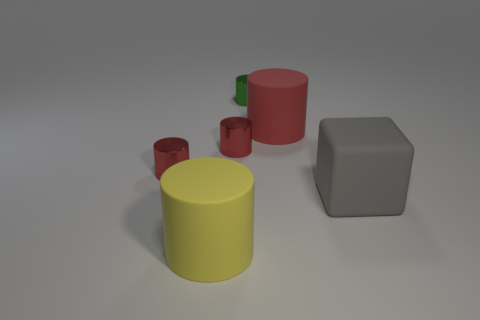How many red cylinders must be subtracted to get 2 red cylinders? 1 Subtract all red spheres. How many red cylinders are left? 3 Subtract all red rubber cylinders. How many cylinders are left? 4 Subtract all green cylinders. How many cylinders are left? 4 Add 2 green shiny things. How many objects exist? 8 Subtract all blue cylinders. Subtract all purple balls. How many cylinders are left? 5 Subtract all cylinders. How many objects are left? 1 Subtract 0 red spheres. How many objects are left? 6 Subtract all tiny red balls. Subtract all large red matte cylinders. How many objects are left? 5 Add 1 big red things. How many big red things are left? 2 